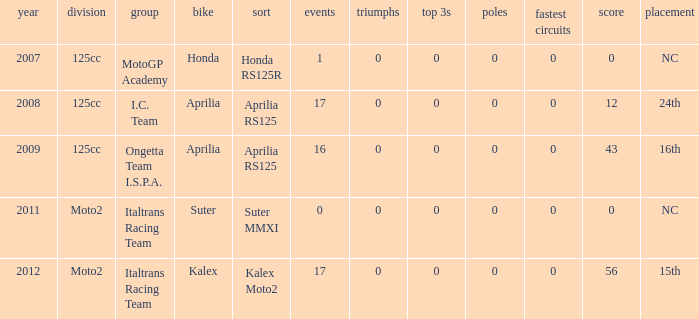What's the name of the team who had a Honda motorcycle? MotoGP Academy. 